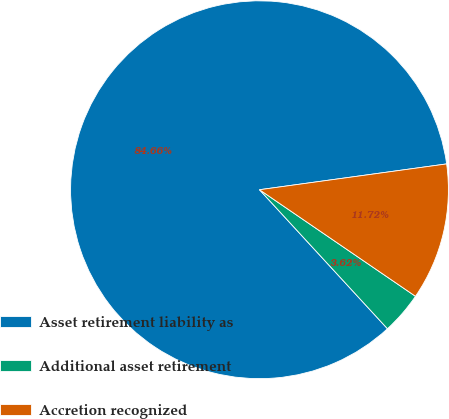Convert chart to OTSL. <chart><loc_0><loc_0><loc_500><loc_500><pie_chart><fcel>Asset retirement liability as<fcel>Additional asset retirement<fcel>Accretion recognized<nl><fcel>84.66%<fcel>3.62%<fcel>11.72%<nl></chart> 